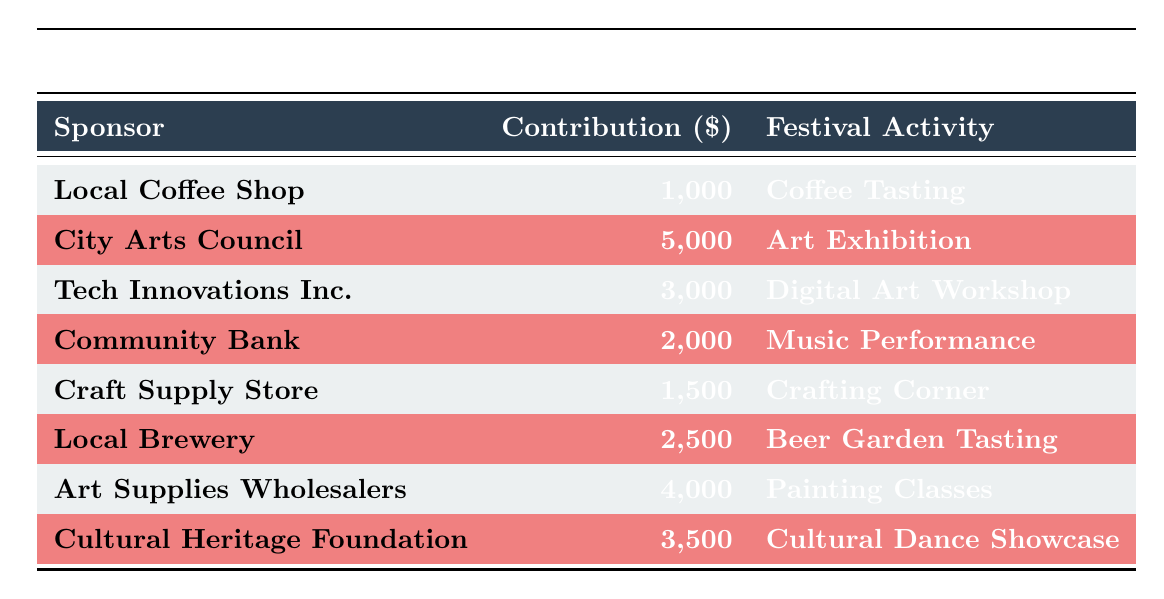What is the contribution amount from the City Arts Council? The table lists the contributions from various sponsors, and under "City Arts Council," the contribution amount is specified as 5000.
Answer: 5000 Which festival activity is sponsored by the Local Coffee Shop? The table indicates that the Local Coffee Shop is associated with the activity "Coffee Tasting."
Answer: Coffee Tasting What is the total contribution amount from all sponsors? To find the total contribution, we add up all the contribution amounts: 1000 + 5000 + 3000 + 2000 + 1500 + 2500 + 4000 + 3500 = 19500.
Answer: 19500 Is the Beer Garden Tasting sponsored by a local establishment? The table shows that the sponsor for "Beer Garden Tasting" is the Local Brewery, which is a local establishment. Thus, the answer is true.
Answer: True Which sponsor contributed the least amount, and what was that amount? By examining the contribution amounts in the table, the least contribution is from the Local Coffee Shop, which contributed 1000.
Answer: Local Coffee Shop, 1000 What is the average contribution amount among all sponsors? The total contribution amount is 19500, and there are 8 sponsors, so we calculate the average as 19500 / 8 = 2437.5.
Answer: 2437.5 Does any sponsor contribute more than 2500? Checking the contribution amounts in the table, the City Arts Council (5000), Tech Innovations Inc. (3000), Art Supplies Wholesalers (4000), and Cultural Heritage Foundation (3500) all exceed 2500, confirming that yes, there are sponsors who contribute more.
Answer: Yes Which festival activity has the second highest contribution amount? The contributions sorted in descending order show that the City Arts Council supports the "Art Exhibition" at 5000, and the second highest is "Painting Classes" by Art Supplies Wholesalers at 4000.
Answer: Painting Classes 